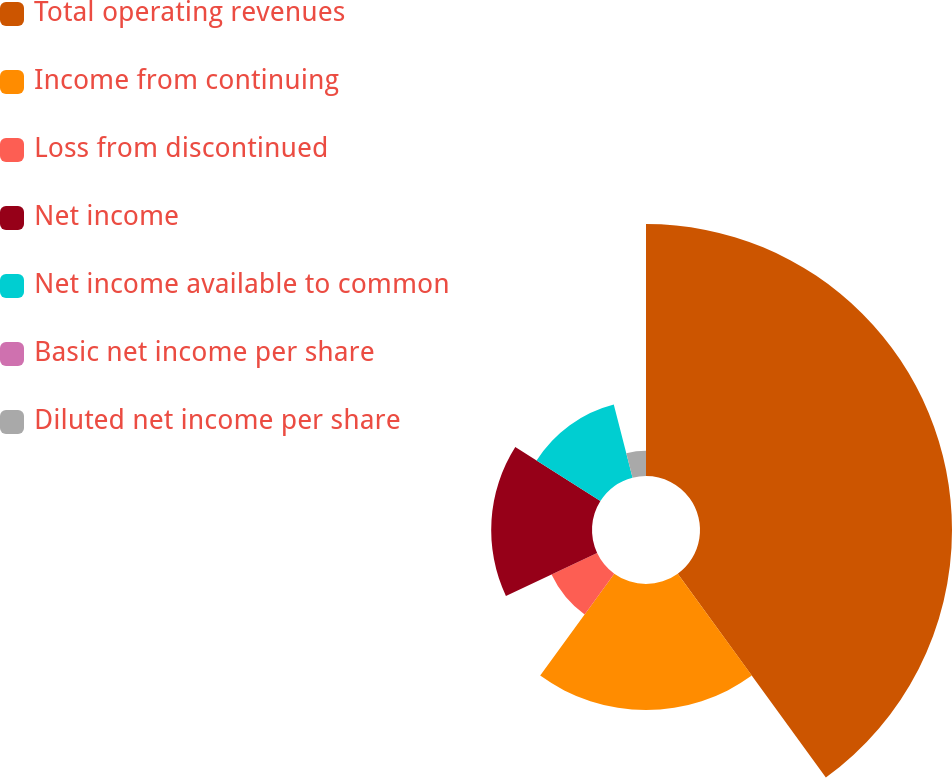Convert chart. <chart><loc_0><loc_0><loc_500><loc_500><pie_chart><fcel>Total operating revenues<fcel>Income from continuing<fcel>Loss from discontinued<fcel>Net income<fcel>Net income available to common<fcel>Basic net income per share<fcel>Diluted net income per share<nl><fcel>40.0%<fcel>20.0%<fcel>8.0%<fcel>16.0%<fcel>12.0%<fcel>0.0%<fcel>4.0%<nl></chart> 